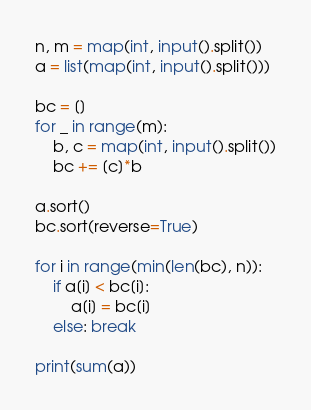<code> <loc_0><loc_0><loc_500><loc_500><_Python_>n, m = map(int, input().split())
a = list(map(int, input().split()))

bc = []
for _ in range(m):
    b, c = map(int, input().split())
    bc += [c]*b

a.sort()
bc.sort(reverse=True)

for i in range(min(len(bc), n)):
    if a[i] < bc[i]:
        a[i] = bc[i]
    else: break

print(sum(a))
</code> 